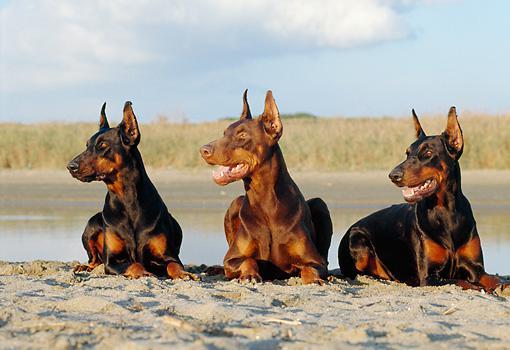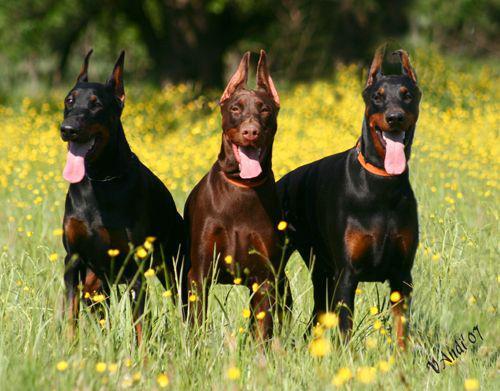The first image is the image on the left, the second image is the image on the right. Given the left and right images, does the statement "The dogs are all sitting in leaves." hold true? Answer yes or no. No. The first image is the image on the left, the second image is the image on the right. Evaluate the accuracy of this statement regarding the images: "At least one image features a doberman sitting upright in autumn foliage, and all dobermans are in some pose on autumn foilage.". Is it true? Answer yes or no. No. 